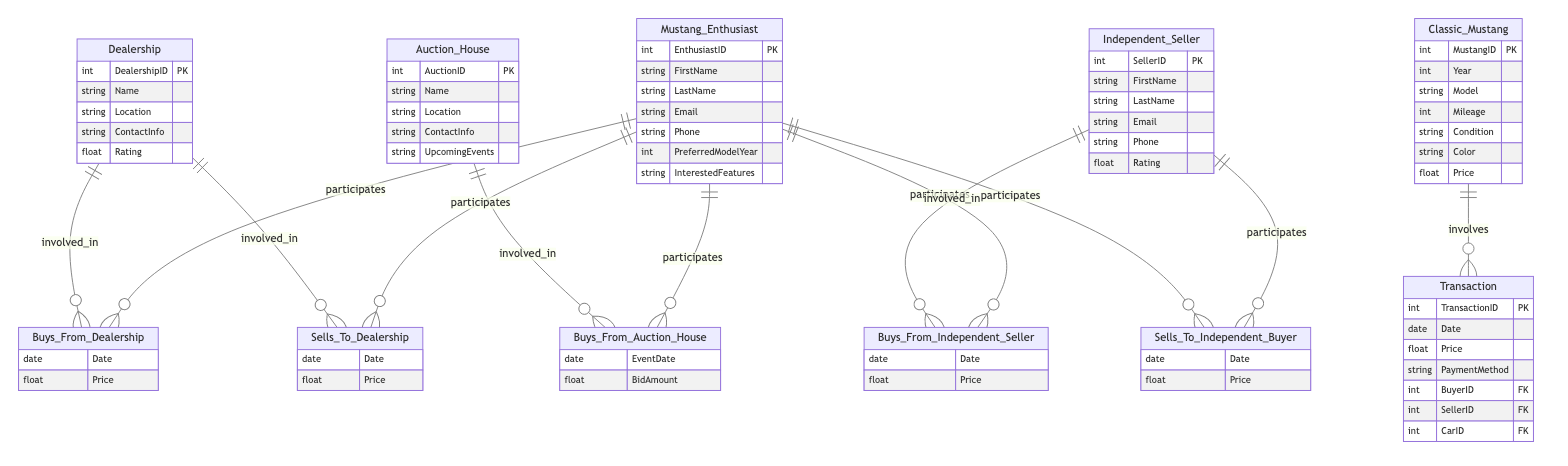What is the primary entity representing buyers in the diagram? The primary entity representing buyers in the diagram is "Mustang_Enthusiast." This can be identified as it is the first entity listed and is involved in multiple relationships indicating purchasing from dealerships, independent sellers, and auction houses.
Answer: Mustang_Enthusiast How many types of sellers are represented in the diagram? There are three types of sellers represented in the diagram: "Dealership," "Independent_Seller," and "Auction_House." Each has its own distinct entity, which can be counted to find that there are three types.
Answer: Three What is the relationship type between Mustang_Enthusiast and Dealership? The relationship type between "Mustang_Enthusiast" and "Dealership" is "Buys_From_Dealership." This is evident from the relationship labeled in the diagram connecting these two entities directly, indicating the nature of the interaction.
Answer: Buys_From_Dealership What information does the "Transaction" entity require for identification? The "Transaction" entity requires three pieces of information for identification: "BuyerID," "SellerID," and "CarID." These attributes function as foreign keys that connect transactions to the specific enthusiasts, sellers, and classic Mustangs involved in the sale.
Answer: BuyerID, SellerID, CarID Which seller type is specifically related to independent buyers? The seller type specifically related to independent buyers is "Independent_Seller." This is confirmed by the relationship "Sells_To_Independent_Buyer," which explicitly connects the Independent Seller to transactions with independent buyers.
Answer: Independent_Seller What does the "Auction_House" entity list as an attribute? The "Auction_House" entity lists "UpcomingEvents" as an attribute. This is directly stated in the attributes section of the Auction_House entity and indicates relevant information about events related to the auction houses.
Answer: UpcomingEvents Which entity has a relationship indicating how enthusiasts sell to dealerships? The entity with a relationship indicating how enthusiasts sell to dealerships is "Mustang_Enthusiast." The relationship is labeled "Sells_To_Dealership," clearly showing that enthusiasts can sell their classic Mustangs to dealerships.
Answer: Mustang_Enthusiast What are the two attributes found in the relationship "Buys_From_Auction_House"? The two attributes found in the relationship "Buys_From_Auction_House" are "EventDate" and "BidAmount." This information can be directly sourced from the details provided under that specific relationship in the diagram.
Answer: EventDate, BidAmount 